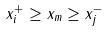<formula> <loc_0><loc_0><loc_500><loc_500>x _ { i } ^ { + } \geq x _ { m } \geq x _ { j } ^ { - }</formula> 